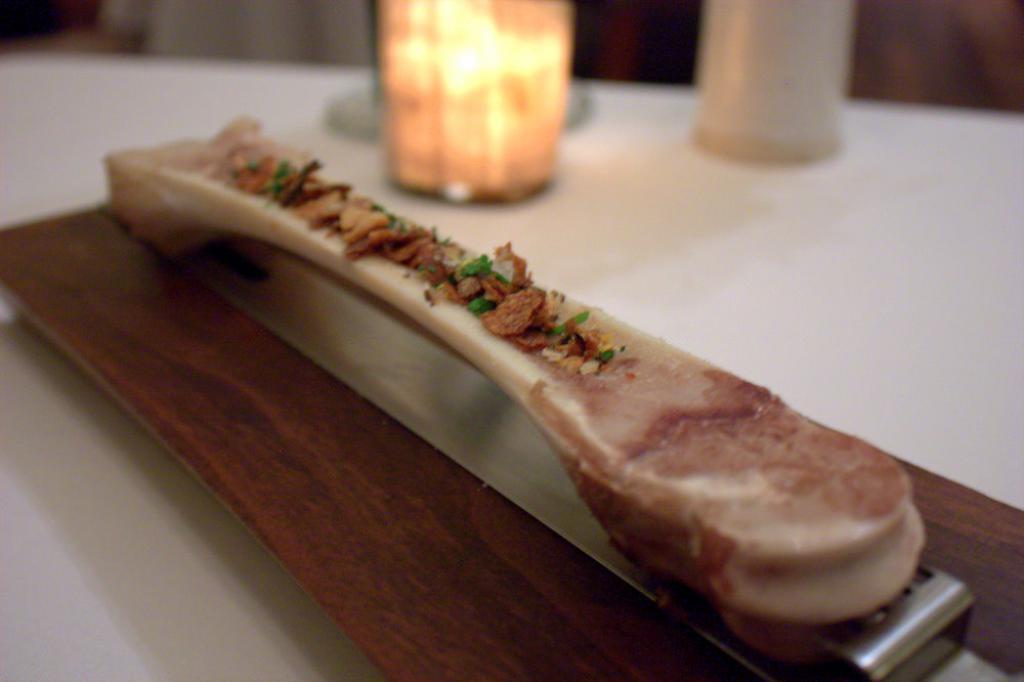How would you summarize this image in a sentence or two? It's a food item on a wooden board. 